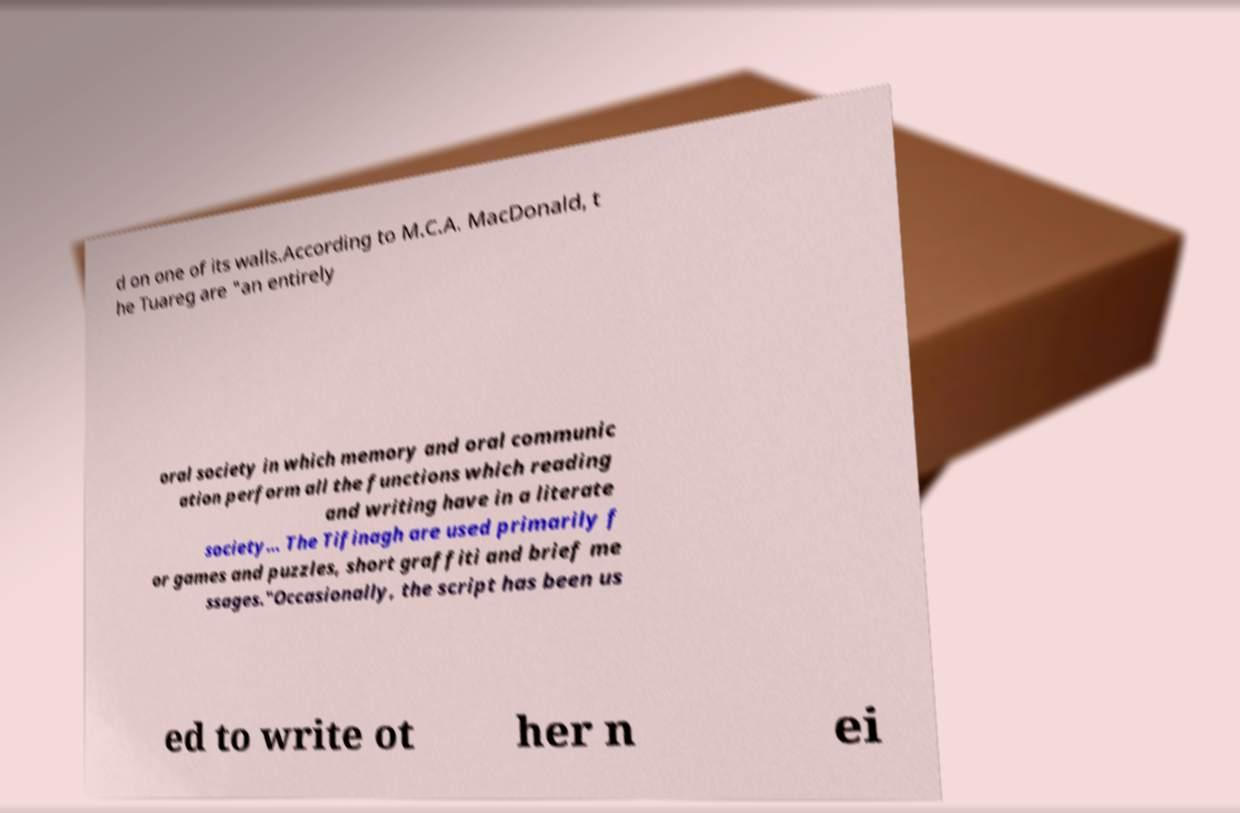Could you extract and type out the text from this image? d on one of its walls.According to M.C.A. MacDonald, t he Tuareg are "an entirely oral society in which memory and oral communic ation perform all the functions which reading and writing have in a literate society… The Tifinagh are used primarily f or games and puzzles, short graffiti and brief me ssages."Occasionally, the script has been us ed to write ot her n ei 